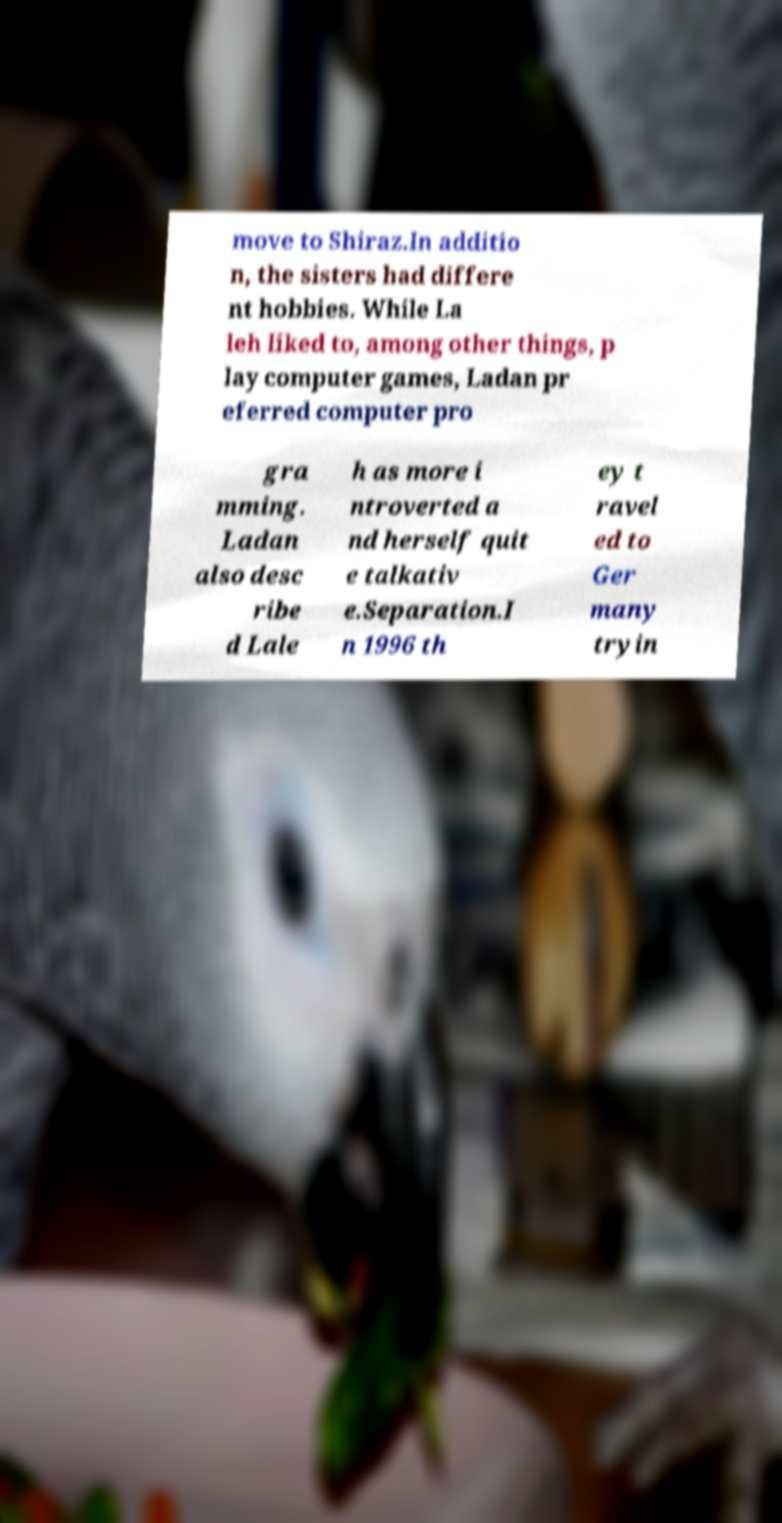For documentation purposes, I need the text within this image transcribed. Could you provide that? move to Shiraz.In additio n, the sisters had differe nt hobbies. While La leh liked to, among other things, p lay computer games, Ladan pr eferred computer pro gra mming. Ladan also desc ribe d Lale h as more i ntroverted a nd herself quit e talkativ e.Separation.I n 1996 th ey t ravel ed to Ger many tryin 